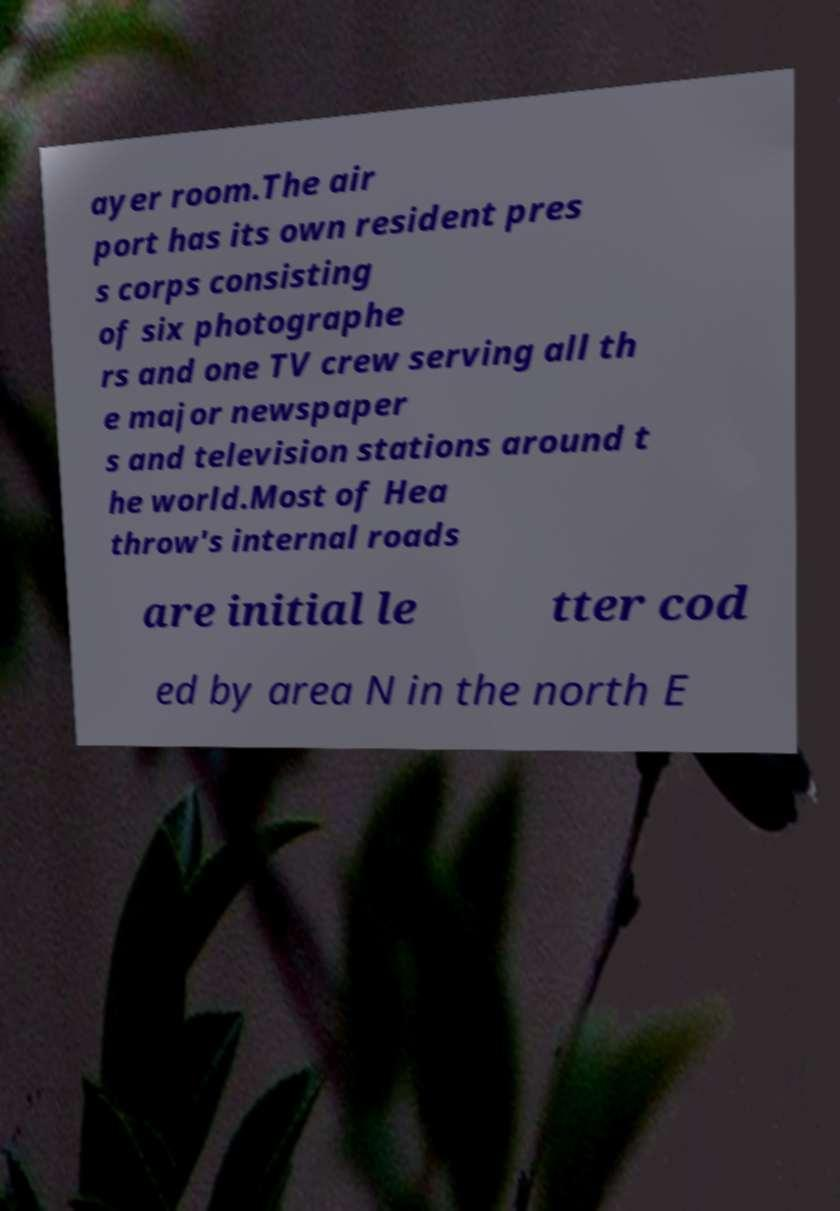There's text embedded in this image that I need extracted. Can you transcribe it verbatim? ayer room.The air port has its own resident pres s corps consisting of six photographe rs and one TV crew serving all th e major newspaper s and television stations around t he world.Most of Hea throw's internal roads are initial le tter cod ed by area N in the north E 